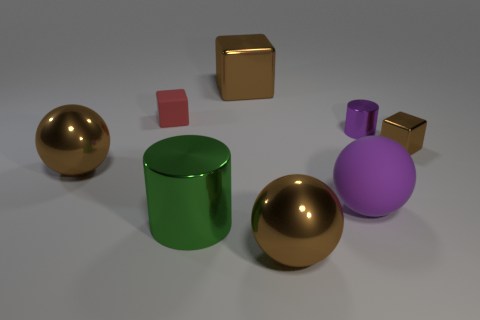Add 1 gray rubber blocks. How many objects exist? 9 Subtract all balls. How many objects are left? 5 Add 3 small brown shiny things. How many small brown shiny things are left? 4 Add 4 tiny things. How many tiny things exist? 7 Subtract 1 purple cylinders. How many objects are left? 7 Subtract all big things. Subtract all large red metal cubes. How many objects are left? 3 